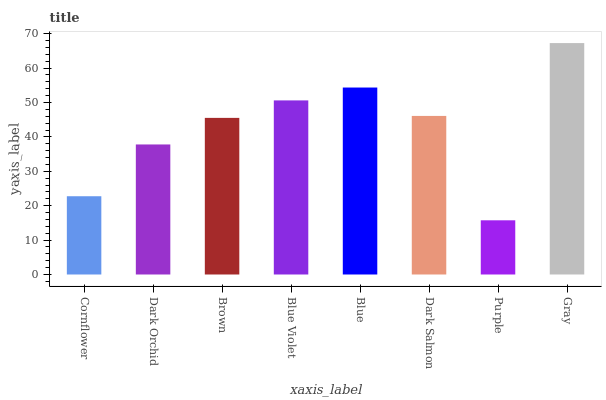Is Purple the minimum?
Answer yes or no. Yes. Is Gray the maximum?
Answer yes or no. Yes. Is Dark Orchid the minimum?
Answer yes or no. No. Is Dark Orchid the maximum?
Answer yes or no. No. Is Dark Orchid greater than Cornflower?
Answer yes or no. Yes. Is Cornflower less than Dark Orchid?
Answer yes or no. Yes. Is Cornflower greater than Dark Orchid?
Answer yes or no. No. Is Dark Orchid less than Cornflower?
Answer yes or no. No. Is Dark Salmon the high median?
Answer yes or no. Yes. Is Brown the low median?
Answer yes or no. Yes. Is Purple the high median?
Answer yes or no. No. Is Purple the low median?
Answer yes or no. No. 